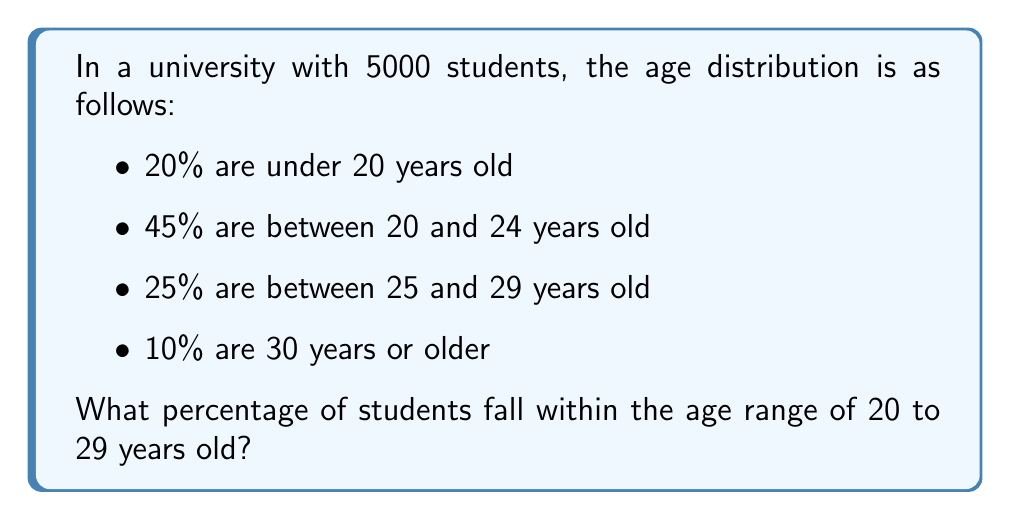Can you solve this math problem? To solve this problem, we need to follow these steps:

1. Identify the relevant age groups:
   - Between 20 and 24 years old: 45%
   - Between 25 and 29 years old: 25%

2. Add the percentages of these two groups:
   $45\% + 25\% = 70\%$

3. Verify the result:
   We can check that the sum of all percentages equals 100%:
   $20\% + 45\% + 25\% + 10\% = 100\%$

Therefore, the percentage of students within the age range of 20 to 29 years old is 70%.
Answer: 70% 